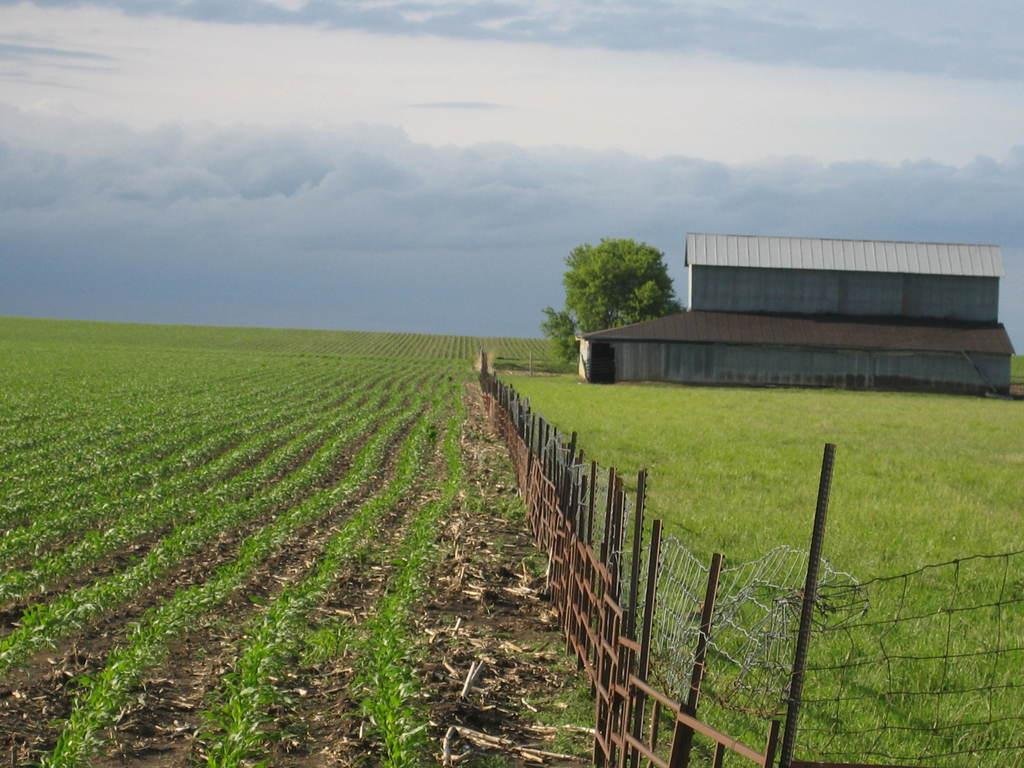What type of ground surface is visible in the image? There is grass on the ground in the image. What type of barrier can be seen in the image? There is a metal fence in the image. What type of vegetation is present in the image? There are trees in the image. What type of structure is visible in the image? There is a house in the image. What is the condition of the sky in the image? The sky is cloudy in the image. Can you see the queen visiting the house in the image? There is no queen or any indication of a visit in the image. What type of hand is holding the metal fence in the image? There are no hands visible in the image; only the metal fence itself is present. 